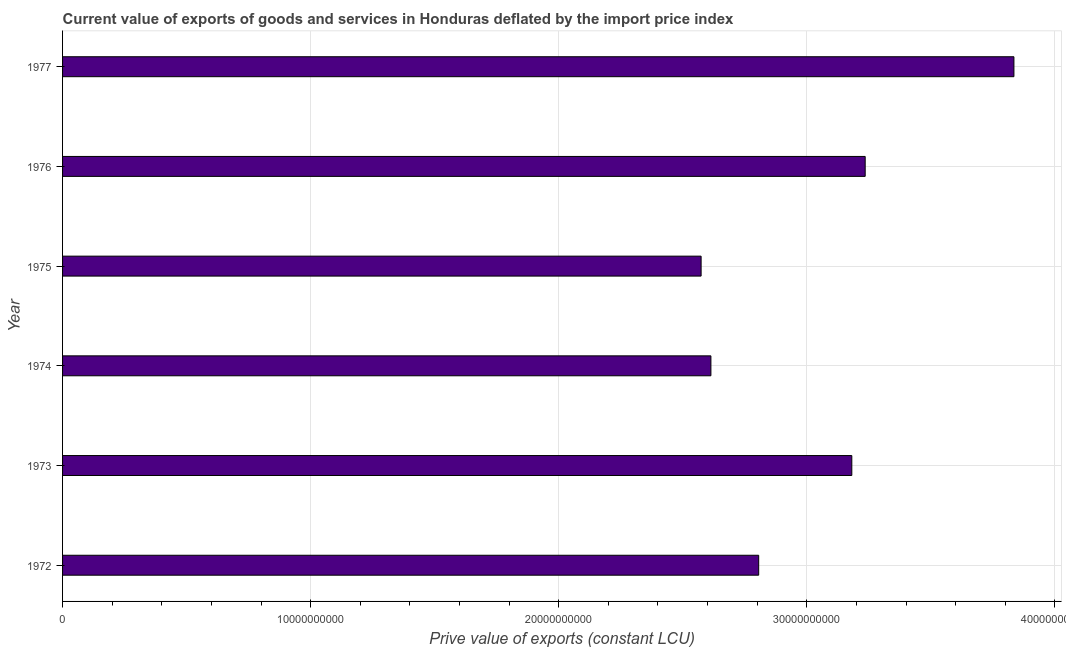What is the title of the graph?
Ensure brevity in your answer.  Current value of exports of goods and services in Honduras deflated by the import price index. What is the label or title of the X-axis?
Provide a succinct answer. Prive value of exports (constant LCU). What is the label or title of the Y-axis?
Provide a short and direct response. Year. What is the price value of exports in 1973?
Your response must be concise. 3.18e+1. Across all years, what is the maximum price value of exports?
Provide a short and direct response. 3.83e+1. Across all years, what is the minimum price value of exports?
Offer a terse response. 2.57e+1. In which year was the price value of exports maximum?
Make the answer very short. 1977. In which year was the price value of exports minimum?
Your answer should be compact. 1975. What is the sum of the price value of exports?
Provide a short and direct response. 1.82e+11. What is the difference between the price value of exports in 1973 and 1975?
Ensure brevity in your answer.  6.08e+09. What is the average price value of exports per year?
Your answer should be very brief. 3.04e+1. What is the median price value of exports?
Provide a succinct answer. 2.99e+1. In how many years, is the price value of exports greater than 36000000000 LCU?
Provide a short and direct response. 1. What is the ratio of the price value of exports in 1973 to that in 1974?
Offer a terse response. 1.22. Is the price value of exports in 1975 less than that in 1976?
Offer a terse response. Yes. What is the difference between the highest and the second highest price value of exports?
Offer a very short reply. 6.00e+09. What is the difference between the highest and the lowest price value of exports?
Keep it short and to the point. 1.26e+1. Are all the bars in the graph horizontal?
Offer a very short reply. Yes. How many years are there in the graph?
Provide a short and direct response. 6. What is the difference between two consecutive major ticks on the X-axis?
Provide a short and direct response. 1.00e+1. What is the Prive value of exports (constant LCU) of 1972?
Ensure brevity in your answer.  2.81e+1. What is the Prive value of exports (constant LCU) of 1973?
Offer a very short reply. 3.18e+1. What is the Prive value of exports (constant LCU) in 1974?
Your answer should be very brief. 2.61e+1. What is the Prive value of exports (constant LCU) in 1975?
Your answer should be compact. 2.57e+1. What is the Prive value of exports (constant LCU) in 1976?
Ensure brevity in your answer.  3.24e+1. What is the Prive value of exports (constant LCU) in 1977?
Make the answer very short. 3.83e+1. What is the difference between the Prive value of exports (constant LCU) in 1972 and 1973?
Make the answer very short. -3.75e+09. What is the difference between the Prive value of exports (constant LCU) in 1972 and 1974?
Your response must be concise. 1.93e+09. What is the difference between the Prive value of exports (constant LCU) in 1972 and 1975?
Provide a short and direct response. 2.32e+09. What is the difference between the Prive value of exports (constant LCU) in 1972 and 1976?
Offer a very short reply. -4.29e+09. What is the difference between the Prive value of exports (constant LCU) in 1972 and 1977?
Provide a succinct answer. -1.03e+1. What is the difference between the Prive value of exports (constant LCU) in 1973 and 1974?
Ensure brevity in your answer.  5.68e+09. What is the difference between the Prive value of exports (constant LCU) in 1973 and 1975?
Your response must be concise. 6.08e+09. What is the difference between the Prive value of exports (constant LCU) in 1973 and 1976?
Offer a terse response. -5.39e+08. What is the difference between the Prive value of exports (constant LCU) in 1973 and 1977?
Provide a succinct answer. -6.53e+09. What is the difference between the Prive value of exports (constant LCU) in 1974 and 1975?
Provide a short and direct response. 3.95e+08. What is the difference between the Prive value of exports (constant LCU) in 1974 and 1976?
Your response must be concise. -6.22e+09. What is the difference between the Prive value of exports (constant LCU) in 1974 and 1977?
Your answer should be very brief. -1.22e+1. What is the difference between the Prive value of exports (constant LCU) in 1975 and 1976?
Your answer should be very brief. -6.61e+09. What is the difference between the Prive value of exports (constant LCU) in 1975 and 1977?
Your answer should be compact. -1.26e+1. What is the difference between the Prive value of exports (constant LCU) in 1976 and 1977?
Keep it short and to the point. -6.00e+09. What is the ratio of the Prive value of exports (constant LCU) in 1972 to that in 1973?
Your response must be concise. 0.88. What is the ratio of the Prive value of exports (constant LCU) in 1972 to that in 1974?
Make the answer very short. 1.07. What is the ratio of the Prive value of exports (constant LCU) in 1972 to that in 1975?
Keep it short and to the point. 1.09. What is the ratio of the Prive value of exports (constant LCU) in 1972 to that in 1976?
Offer a very short reply. 0.87. What is the ratio of the Prive value of exports (constant LCU) in 1972 to that in 1977?
Keep it short and to the point. 0.73. What is the ratio of the Prive value of exports (constant LCU) in 1973 to that in 1974?
Your answer should be very brief. 1.22. What is the ratio of the Prive value of exports (constant LCU) in 1973 to that in 1975?
Offer a terse response. 1.24. What is the ratio of the Prive value of exports (constant LCU) in 1973 to that in 1977?
Provide a succinct answer. 0.83. What is the ratio of the Prive value of exports (constant LCU) in 1974 to that in 1976?
Provide a short and direct response. 0.81. What is the ratio of the Prive value of exports (constant LCU) in 1974 to that in 1977?
Ensure brevity in your answer.  0.68. What is the ratio of the Prive value of exports (constant LCU) in 1975 to that in 1976?
Provide a short and direct response. 0.8. What is the ratio of the Prive value of exports (constant LCU) in 1975 to that in 1977?
Offer a very short reply. 0.67. What is the ratio of the Prive value of exports (constant LCU) in 1976 to that in 1977?
Your answer should be very brief. 0.84. 